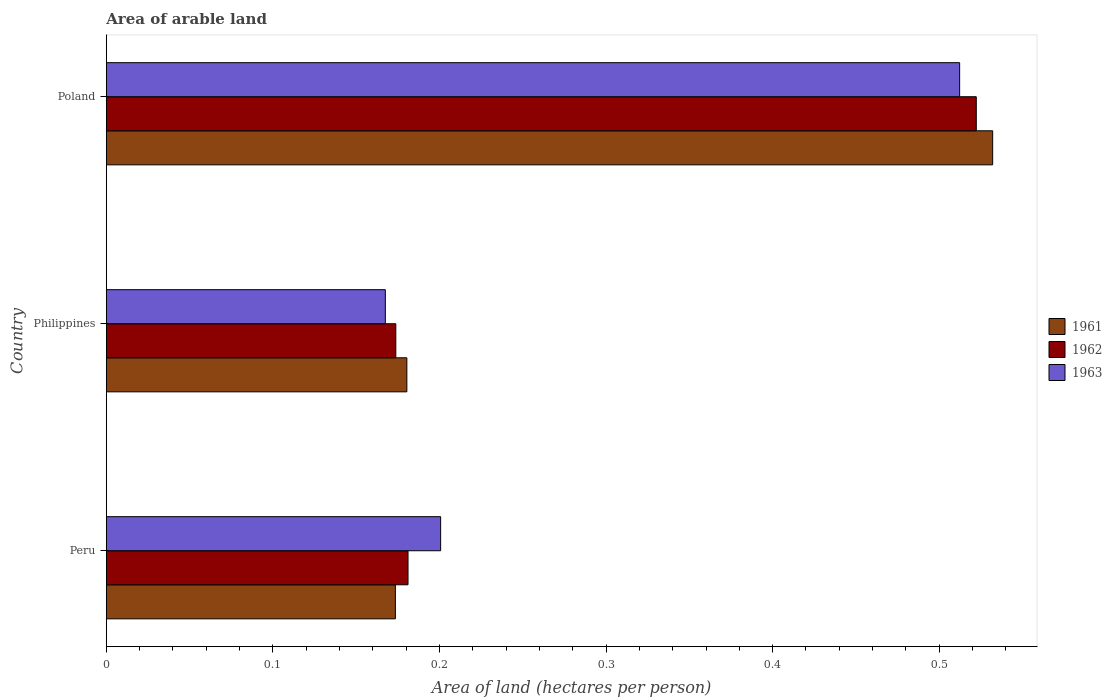Are the number of bars on each tick of the Y-axis equal?
Provide a succinct answer. Yes. In how many cases, is the number of bars for a given country not equal to the number of legend labels?
Provide a succinct answer. 0. What is the total arable land in 1961 in Peru?
Offer a terse response. 0.17. Across all countries, what is the maximum total arable land in 1963?
Keep it short and to the point. 0.51. Across all countries, what is the minimum total arable land in 1962?
Offer a very short reply. 0.17. What is the total total arable land in 1963 in the graph?
Offer a very short reply. 0.88. What is the difference between the total arable land in 1961 in Peru and that in Poland?
Keep it short and to the point. -0.36. What is the difference between the total arable land in 1961 in Peru and the total arable land in 1962 in Philippines?
Your answer should be very brief. -0. What is the average total arable land in 1963 per country?
Your answer should be very brief. 0.29. What is the difference between the total arable land in 1962 and total arable land in 1961 in Poland?
Provide a short and direct response. -0.01. What is the ratio of the total arable land in 1962 in Peru to that in Philippines?
Your response must be concise. 1.04. What is the difference between the highest and the second highest total arable land in 1963?
Offer a terse response. 0.31. What is the difference between the highest and the lowest total arable land in 1961?
Offer a very short reply. 0.36. Is the sum of the total arable land in 1961 in Peru and Poland greater than the maximum total arable land in 1963 across all countries?
Ensure brevity in your answer.  Yes. How many bars are there?
Your answer should be compact. 9. Are all the bars in the graph horizontal?
Ensure brevity in your answer.  Yes. What is the difference between two consecutive major ticks on the X-axis?
Offer a terse response. 0.1. Does the graph contain grids?
Provide a short and direct response. No. Where does the legend appear in the graph?
Offer a very short reply. Center right. What is the title of the graph?
Your answer should be very brief. Area of arable land. What is the label or title of the X-axis?
Ensure brevity in your answer.  Area of land (hectares per person). What is the Area of land (hectares per person) in 1961 in Peru?
Your answer should be compact. 0.17. What is the Area of land (hectares per person) in 1962 in Peru?
Provide a succinct answer. 0.18. What is the Area of land (hectares per person) of 1963 in Peru?
Keep it short and to the point. 0.2. What is the Area of land (hectares per person) of 1961 in Philippines?
Your answer should be compact. 0.18. What is the Area of land (hectares per person) of 1962 in Philippines?
Offer a terse response. 0.17. What is the Area of land (hectares per person) of 1963 in Philippines?
Give a very brief answer. 0.17. What is the Area of land (hectares per person) in 1961 in Poland?
Offer a very short reply. 0.53. What is the Area of land (hectares per person) of 1962 in Poland?
Offer a very short reply. 0.52. What is the Area of land (hectares per person) in 1963 in Poland?
Provide a short and direct response. 0.51. Across all countries, what is the maximum Area of land (hectares per person) in 1961?
Your answer should be compact. 0.53. Across all countries, what is the maximum Area of land (hectares per person) in 1962?
Your answer should be very brief. 0.52. Across all countries, what is the maximum Area of land (hectares per person) of 1963?
Your answer should be very brief. 0.51. Across all countries, what is the minimum Area of land (hectares per person) of 1961?
Offer a terse response. 0.17. Across all countries, what is the minimum Area of land (hectares per person) of 1962?
Keep it short and to the point. 0.17. Across all countries, what is the minimum Area of land (hectares per person) of 1963?
Provide a short and direct response. 0.17. What is the total Area of land (hectares per person) in 1961 in the graph?
Ensure brevity in your answer.  0.89. What is the total Area of land (hectares per person) of 1962 in the graph?
Your response must be concise. 0.88. What is the total Area of land (hectares per person) of 1963 in the graph?
Offer a terse response. 0.88. What is the difference between the Area of land (hectares per person) of 1961 in Peru and that in Philippines?
Provide a short and direct response. -0.01. What is the difference between the Area of land (hectares per person) in 1962 in Peru and that in Philippines?
Your answer should be compact. 0.01. What is the difference between the Area of land (hectares per person) in 1963 in Peru and that in Philippines?
Your answer should be very brief. 0.03. What is the difference between the Area of land (hectares per person) in 1961 in Peru and that in Poland?
Offer a terse response. -0.36. What is the difference between the Area of land (hectares per person) of 1962 in Peru and that in Poland?
Your answer should be compact. -0.34. What is the difference between the Area of land (hectares per person) in 1963 in Peru and that in Poland?
Your answer should be compact. -0.31. What is the difference between the Area of land (hectares per person) of 1961 in Philippines and that in Poland?
Keep it short and to the point. -0.35. What is the difference between the Area of land (hectares per person) in 1962 in Philippines and that in Poland?
Make the answer very short. -0.35. What is the difference between the Area of land (hectares per person) of 1963 in Philippines and that in Poland?
Provide a succinct answer. -0.34. What is the difference between the Area of land (hectares per person) of 1961 in Peru and the Area of land (hectares per person) of 1962 in Philippines?
Your response must be concise. -0. What is the difference between the Area of land (hectares per person) in 1961 in Peru and the Area of land (hectares per person) in 1963 in Philippines?
Offer a very short reply. 0.01. What is the difference between the Area of land (hectares per person) of 1962 in Peru and the Area of land (hectares per person) of 1963 in Philippines?
Provide a succinct answer. 0.01. What is the difference between the Area of land (hectares per person) in 1961 in Peru and the Area of land (hectares per person) in 1962 in Poland?
Offer a very short reply. -0.35. What is the difference between the Area of land (hectares per person) in 1961 in Peru and the Area of land (hectares per person) in 1963 in Poland?
Your answer should be very brief. -0.34. What is the difference between the Area of land (hectares per person) in 1962 in Peru and the Area of land (hectares per person) in 1963 in Poland?
Offer a terse response. -0.33. What is the difference between the Area of land (hectares per person) of 1961 in Philippines and the Area of land (hectares per person) of 1962 in Poland?
Your answer should be compact. -0.34. What is the difference between the Area of land (hectares per person) of 1961 in Philippines and the Area of land (hectares per person) of 1963 in Poland?
Offer a very short reply. -0.33. What is the difference between the Area of land (hectares per person) of 1962 in Philippines and the Area of land (hectares per person) of 1963 in Poland?
Your answer should be very brief. -0.34. What is the average Area of land (hectares per person) of 1961 per country?
Provide a short and direct response. 0.3. What is the average Area of land (hectares per person) of 1962 per country?
Give a very brief answer. 0.29. What is the average Area of land (hectares per person) in 1963 per country?
Keep it short and to the point. 0.29. What is the difference between the Area of land (hectares per person) of 1961 and Area of land (hectares per person) of 1962 in Peru?
Provide a short and direct response. -0.01. What is the difference between the Area of land (hectares per person) in 1961 and Area of land (hectares per person) in 1963 in Peru?
Your answer should be compact. -0.03. What is the difference between the Area of land (hectares per person) in 1962 and Area of land (hectares per person) in 1963 in Peru?
Provide a short and direct response. -0.02. What is the difference between the Area of land (hectares per person) of 1961 and Area of land (hectares per person) of 1962 in Philippines?
Provide a short and direct response. 0.01. What is the difference between the Area of land (hectares per person) in 1961 and Area of land (hectares per person) in 1963 in Philippines?
Keep it short and to the point. 0.01. What is the difference between the Area of land (hectares per person) of 1962 and Area of land (hectares per person) of 1963 in Philippines?
Provide a succinct answer. 0.01. What is the difference between the Area of land (hectares per person) in 1961 and Area of land (hectares per person) in 1962 in Poland?
Give a very brief answer. 0.01. What is the difference between the Area of land (hectares per person) in 1961 and Area of land (hectares per person) in 1963 in Poland?
Ensure brevity in your answer.  0.02. What is the ratio of the Area of land (hectares per person) in 1961 in Peru to that in Philippines?
Your answer should be compact. 0.96. What is the ratio of the Area of land (hectares per person) of 1962 in Peru to that in Philippines?
Ensure brevity in your answer.  1.04. What is the ratio of the Area of land (hectares per person) of 1963 in Peru to that in Philippines?
Ensure brevity in your answer.  1.2. What is the ratio of the Area of land (hectares per person) of 1961 in Peru to that in Poland?
Make the answer very short. 0.33. What is the ratio of the Area of land (hectares per person) of 1962 in Peru to that in Poland?
Make the answer very short. 0.35. What is the ratio of the Area of land (hectares per person) in 1963 in Peru to that in Poland?
Provide a succinct answer. 0.39. What is the ratio of the Area of land (hectares per person) in 1961 in Philippines to that in Poland?
Give a very brief answer. 0.34. What is the ratio of the Area of land (hectares per person) of 1962 in Philippines to that in Poland?
Offer a terse response. 0.33. What is the ratio of the Area of land (hectares per person) of 1963 in Philippines to that in Poland?
Ensure brevity in your answer.  0.33. What is the difference between the highest and the second highest Area of land (hectares per person) of 1961?
Offer a very short reply. 0.35. What is the difference between the highest and the second highest Area of land (hectares per person) in 1962?
Give a very brief answer. 0.34. What is the difference between the highest and the second highest Area of land (hectares per person) of 1963?
Provide a succinct answer. 0.31. What is the difference between the highest and the lowest Area of land (hectares per person) of 1961?
Provide a succinct answer. 0.36. What is the difference between the highest and the lowest Area of land (hectares per person) in 1962?
Provide a short and direct response. 0.35. What is the difference between the highest and the lowest Area of land (hectares per person) of 1963?
Give a very brief answer. 0.34. 